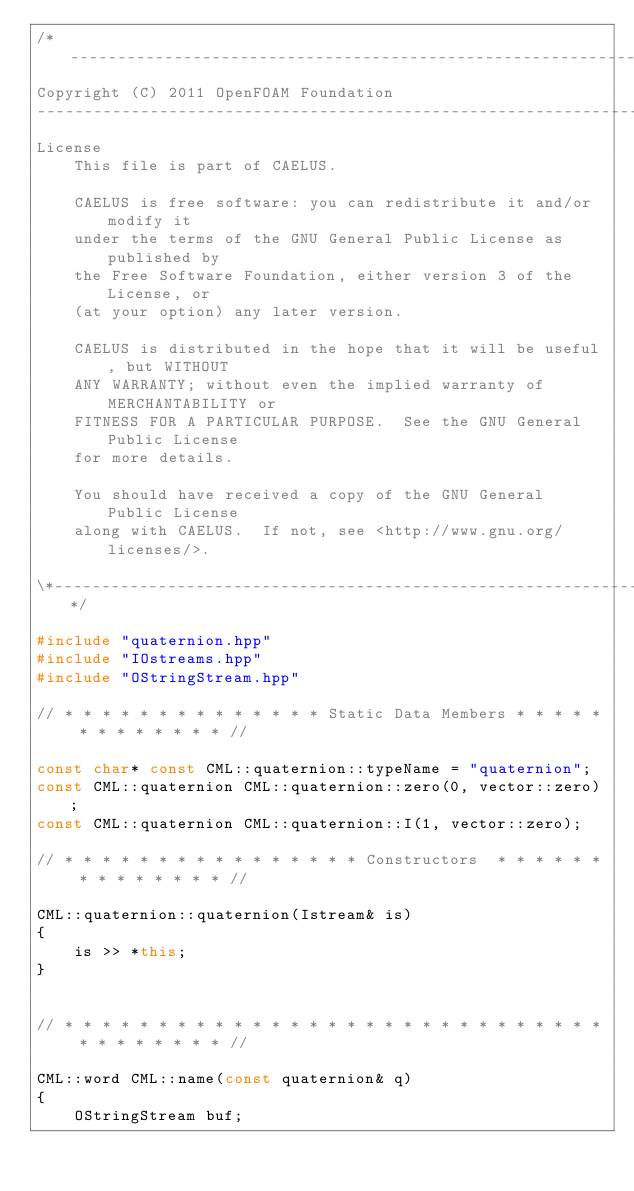Convert code to text. <code><loc_0><loc_0><loc_500><loc_500><_C++_>/*---------------------------------------------------------------------------*\
Copyright (C) 2011 OpenFOAM Foundation
-------------------------------------------------------------------------------
License
    This file is part of CAELUS.

    CAELUS is free software: you can redistribute it and/or modify it
    under the terms of the GNU General Public License as published by
    the Free Software Foundation, either version 3 of the License, or
    (at your option) any later version.

    CAELUS is distributed in the hope that it will be useful, but WITHOUT
    ANY WARRANTY; without even the implied warranty of MERCHANTABILITY or
    FITNESS FOR A PARTICULAR PURPOSE.  See the GNU General Public License
    for more details.

    You should have received a copy of the GNU General Public License
    along with CAELUS.  If not, see <http://www.gnu.org/licenses/>.

\*---------------------------------------------------------------------------*/

#include "quaternion.hpp"
#include "IOstreams.hpp"
#include "OStringStream.hpp"

// * * * * * * * * * * * * * * Static Data Members * * * * * * * * * * * * * //

const char* const CML::quaternion::typeName = "quaternion";
const CML::quaternion CML::quaternion::zero(0, vector::zero);
const CML::quaternion CML::quaternion::I(1, vector::zero);

// * * * * * * * * * * * * * * * * Constructors  * * * * * * * * * * * * * * //

CML::quaternion::quaternion(Istream& is)
{
    is >> *this;
}


// * * * * * * * * * * * * * * * * * * * * * * * * * * * * * * * * * * * * * //

CML::word CML::name(const quaternion& q)
{
    OStringStream buf;</code> 